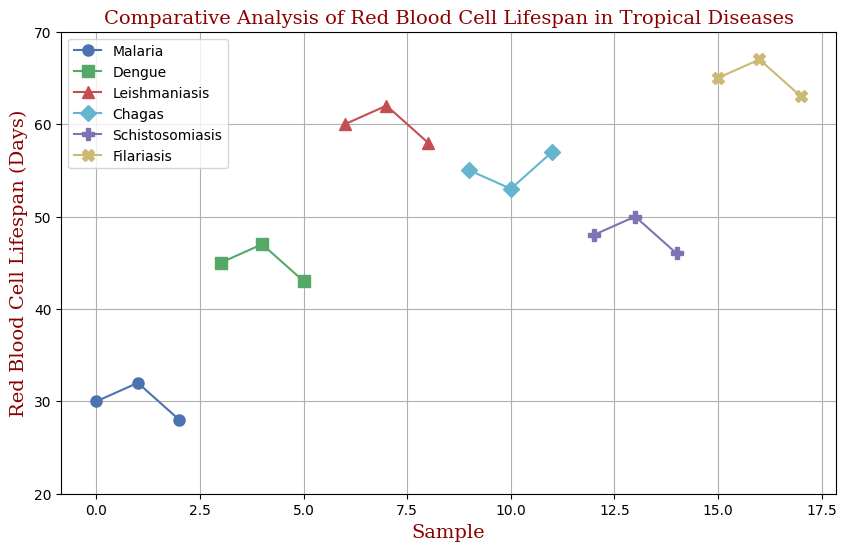Which disease has the shortest average red blood cell lifespan? Looking at the plot, we calculate the average lifespan for each disease by summing the values and dividing by the number of samples. Malaria: (30+32+28)/3 = 30, Dengue: (45+47+43)/3 = 45, Leishmaniasis: (60+62+58)/3 = 60, Chagas: (55+53+57)/3 = 55, Schistosomiasis: (48+50+46)/3 = 48, Filariasis: (65+67+63)/3 = 65. Malaria has the shortest average lifespan.
Answer: Malaria What is the difference in the average red blood cell lifespan between Malaria and Filariasis? First, find the average lifespan for Malaria (30 days) and Filariasis (65 days). The difference is calculated as 65 - 30 = 35.
Answer: 35 Which disease shows the most variability in red blood cell lifespan? To determine variability, consider the range (max value - min value) for each disease in the plot: Malaria: 32 - 28 = 4, Dengue: 47 - 43 = 4, Leishmaniasis: 62 - 58 = 4, Chagas: 57 - 53 = 4, Schistosomiasis: 50 - 46 = 4, Filariasis: 67 - 63 = 4. All diseases show the same variability.
Answer: Equal variability Which disease has the highest maximum red blood cell lifespan? Examine the highest value in each disease group: Malaria (32), Dengue (47), Leishmaniasis (62), Chagas (57), Schistosomiasis (50), Filariasis (67). Filariasis has the highest maximum lifespan.
Answer: Filariasis What is the median red blood cell lifespan for Schistosomiasis? For Schistosomiasis with values [48, 50, 46], sort and find the middle value: sorted list [46, 48, 50]; median is 48.
Answer: 48 Which disease has the lowest minimum red blood cell lifespan? Examine the lowest value in each disease group: Malaria (28), Dengue (43), Leishmaniasis (58), Chagas (53), Schistosomiasis (46), Filariasis (63). Malaria has the lowest minimum lifespan.
Answer: Malaria Is the average red blood cell lifespan for Dengue greater than that for Chagas? First, find the average lifespan for Dengue (45 days) and Chagas (55 days). Compare 45 < 55.
Answer: No How many tropical diseases have average red blood cell lifespans above 50 days? Calculate the average lifespan for each disease and count those above 50 days. Dengue (45), Leishmaniasis (60), Chagas (55), Schistosomiasis (48), Filariasis (65). Three have averages above 50: Leishmaniasis, Chagas, Filariasis.
Answer: 3 